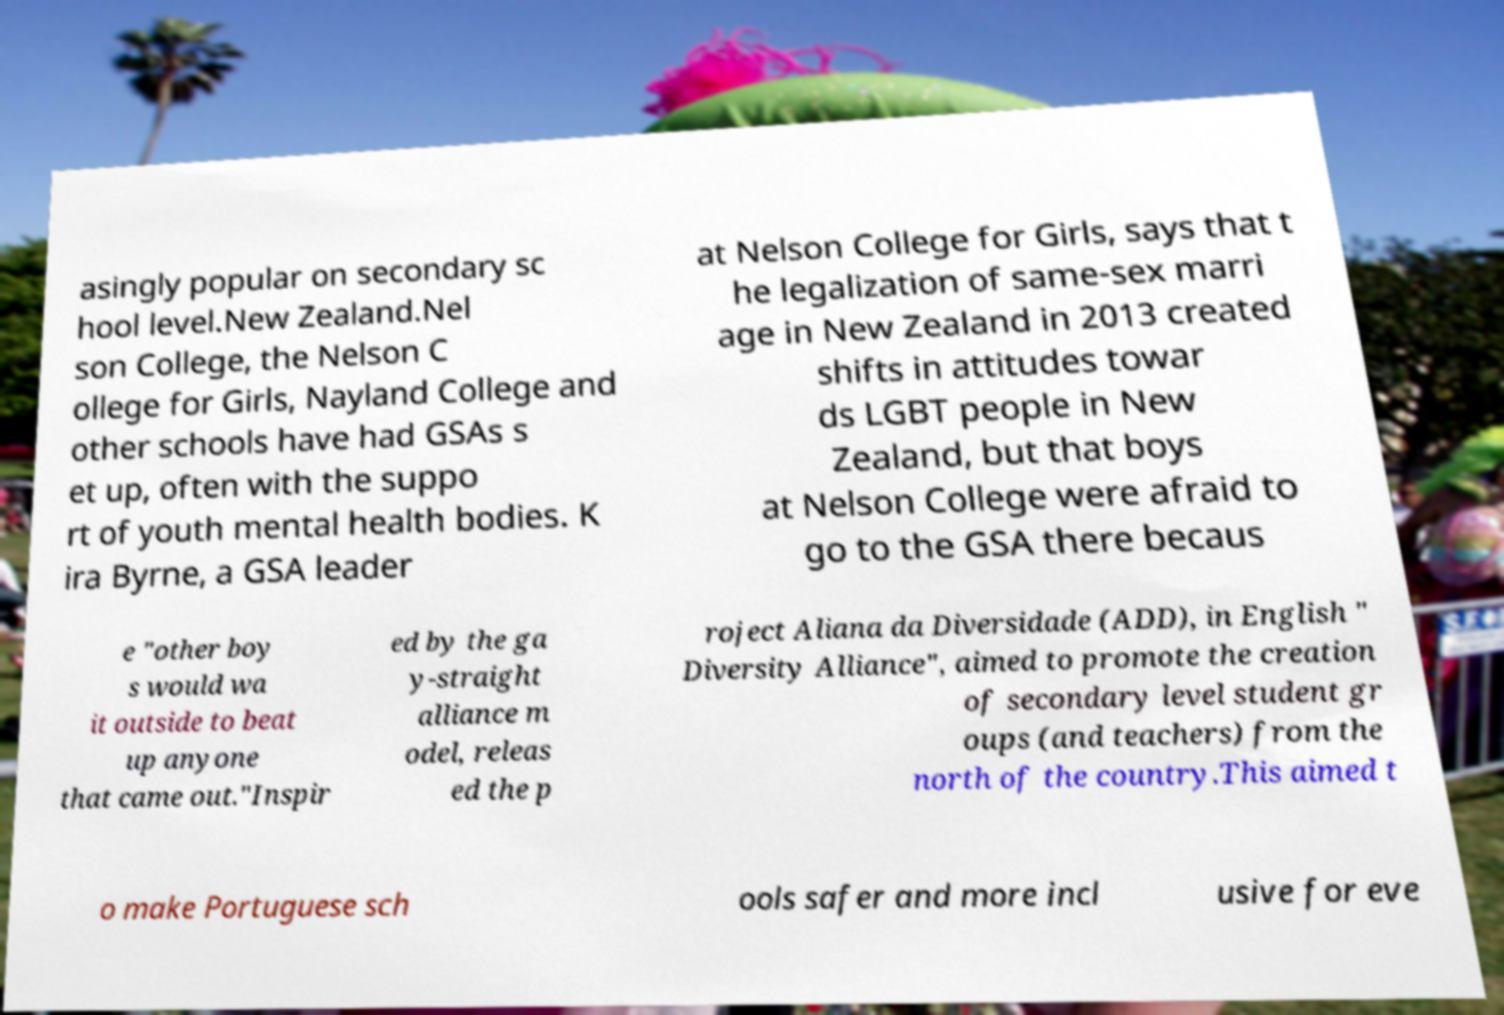Can you accurately transcribe the text from the provided image for me? asingly popular on secondary sc hool level.New Zealand.Nel son College, the Nelson C ollege for Girls, Nayland College and other schools have had GSAs s et up, often with the suppo rt of youth mental health bodies. K ira Byrne, a GSA leader at Nelson College for Girls, says that t he legalization of same-sex marri age in New Zealand in 2013 created shifts in attitudes towar ds LGBT people in New Zealand, but that boys at Nelson College were afraid to go to the GSA there becaus e "other boy s would wa it outside to beat up anyone that came out."Inspir ed by the ga y-straight alliance m odel, releas ed the p roject Aliana da Diversidade (ADD), in English " Diversity Alliance", aimed to promote the creation of secondary level student gr oups (and teachers) from the north of the country.This aimed t o make Portuguese sch ools safer and more incl usive for eve 